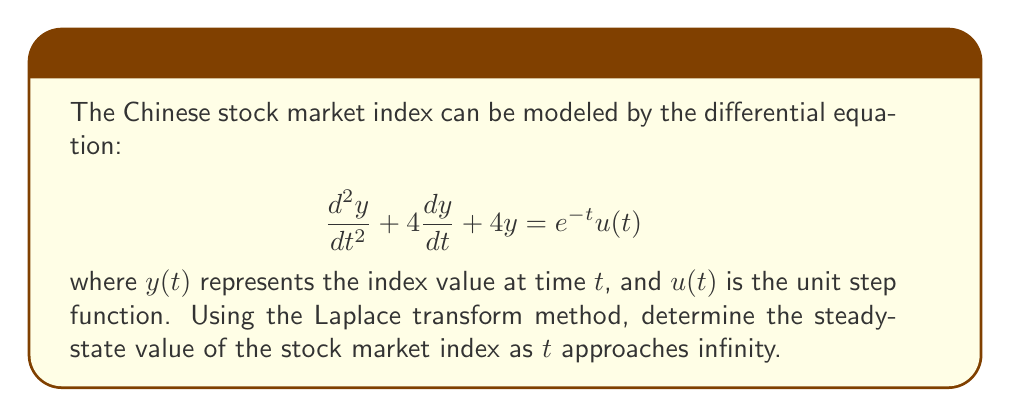Give your solution to this math problem. To solve this problem using the Laplace transform method, we'll follow these steps:

1) Take the Laplace transform of both sides of the equation:
   $$\mathcal{L}\left\{\frac{d^2y}{dt^2} + 4\frac{dy}{dt} + 4y\right\} = \mathcal{L}\{e^{-t}u(t)\}$$

2) Using Laplace transform properties:
   $$(s^2Y(s) - sy(0) - y'(0)) + 4(sY(s) - y(0)) + 4Y(s) = \frac{1}{s+1}$$
   
   Assuming initial conditions $y(0) = 0$ and $y'(0) = 0$:
   
   $$(s^2 + 4s + 4)Y(s) = \frac{1}{s+1}$$

3) Solve for $Y(s)$:
   $$Y(s) = \frac{1}{(s+1)(s^2 + 4s + 4)} = \frac{1}{(s+1)(s+2)^2}$$

4) To find the steady-state value, we need to apply the Final Value Theorem:
   $$\lim_{t \to \infty} y(t) = \lim_{s \to 0} sY(s)$$

5) Calculate the limit:
   $$\lim_{s \to 0} s \cdot \frac{1}{(s+1)(s+2)^2} = \lim_{s \to 0} \frac{s}{(s+1)(s+2)^2} = \frac{0}{(1)(2)^2} = 0$$

Therefore, the steady-state value of the stock market index as $t$ approaches infinity is 0.
Answer: The steady-state value of the Chinese stock market index as $t$ approaches infinity is 0. 